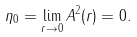<formula> <loc_0><loc_0><loc_500><loc_500>\eta _ { 0 } = \lim _ { r \rightarrow 0 } A ^ { 2 } ( r ) = 0 .</formula> 